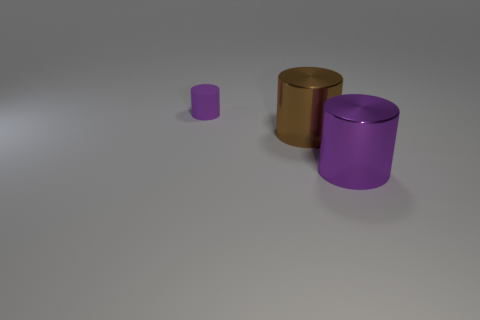Add 1 blue metal cubes. How many objects exist? 4 Subtract all brown metal objects. Subtract all brown cylinders. How many objects are left? 1 Add 3 small purple things. How many small purple things are left? 4 Add 3 brown objects. How many brown objects exist? 4 Subtract 0 gray blocks. How many objects are left? 3 